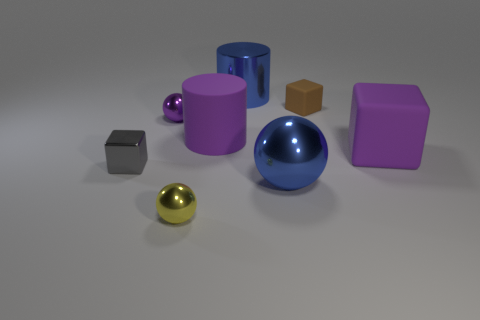Add 2 brown spheres. How many objects exist? 10 Subtract all cylinders. How many objects are left? 6 Subtract 0 cyan cubes. How many objects are left? 8 Subtract all tiny yellow shiny balls. Subtract all purple things. How many objects are left? 4 Add 4 purple objects. How many purple objects are left? 7 Add 2 small metal cubes. How many small metal cubes exist? 3 